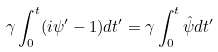Convert formula to latex. <formula><loc_0><loc_0><loc_500><loc_500>\gamma \int _ { 0 } ^ { t } ( i \psi ^ { \prime } - 1 ) d t ^ { \prime } = \gamma \int _ { 0 } ^ { t } \hat { \psi } d t ^ { \prime }</formula> 